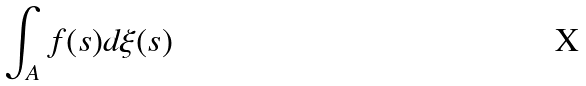<formula> <loc_0><loc_0><loc_500><loc_500>\int _ { A } f ( s ) d \xi ( s )</formula> 